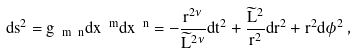<formula> <loc_0><loc_0><loc_500><loc_500>d s ^ { 2 } = g _ { \ m \ n } d x ^ { \ m } d x ^ { \ n } = - \frac { r ^ { 2 \nu } } { \widetilde { L } ^ { 2 \nu } } d t ^ { 2 } + \frac { \widetilde { L } ^ { 2 } } { r ^ { 2 } } d r ^ { 2 } + r ^ { 2 } d \phi ^ { 2 } \, ,</formula> 